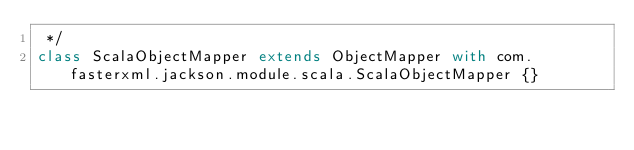<code> <loc_0><loc_0><loc_500><loc_500><_Scala_> */
class ScalaObjectMapper extends ObjectMapper with com.fasterxml.jackson.module.scala.ScalaObjectMapper {}
</code> 